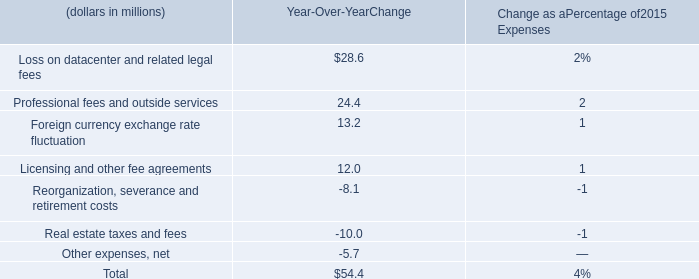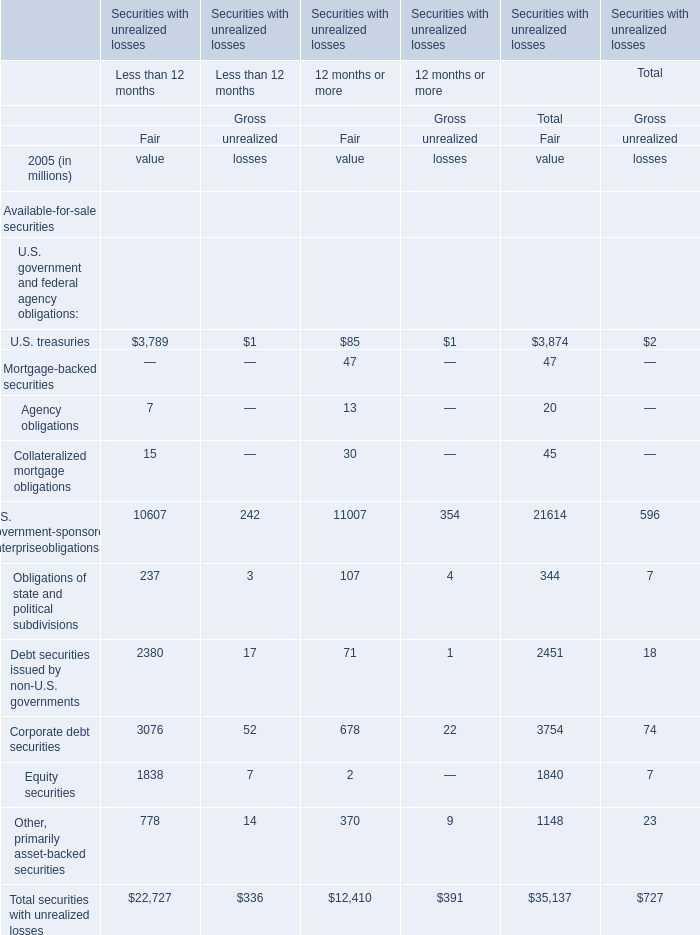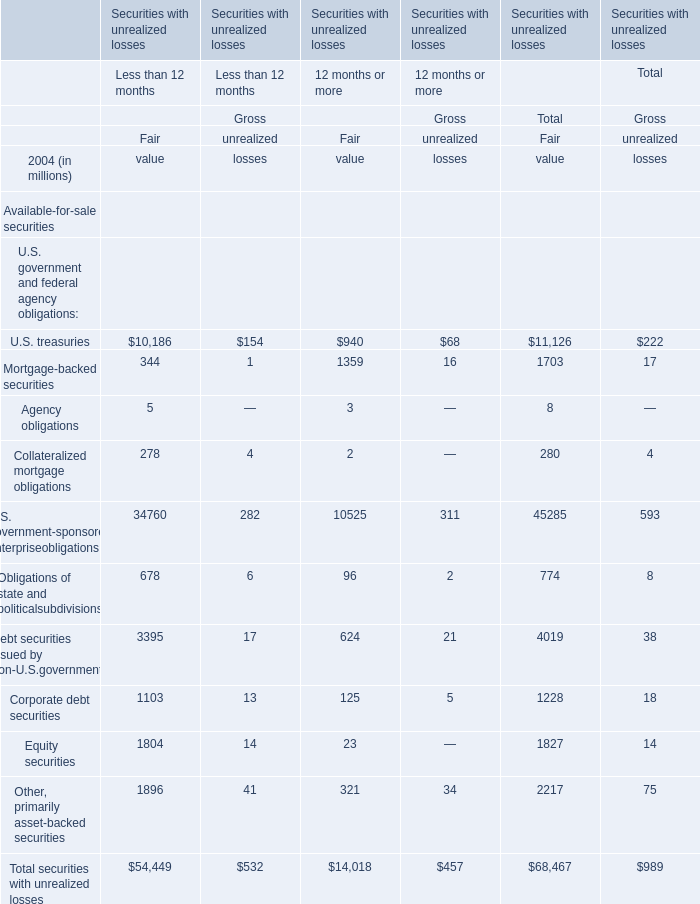What is the percentage of all elements that are positive to the total amount, ifor Fair of 12 months or more? 
Computations: ((((((((((940 + 1359) + 3) + 2) + 10525) + 96) + 624) + 125) + 23) + 321) / 14018)
Answer: 1.0. 